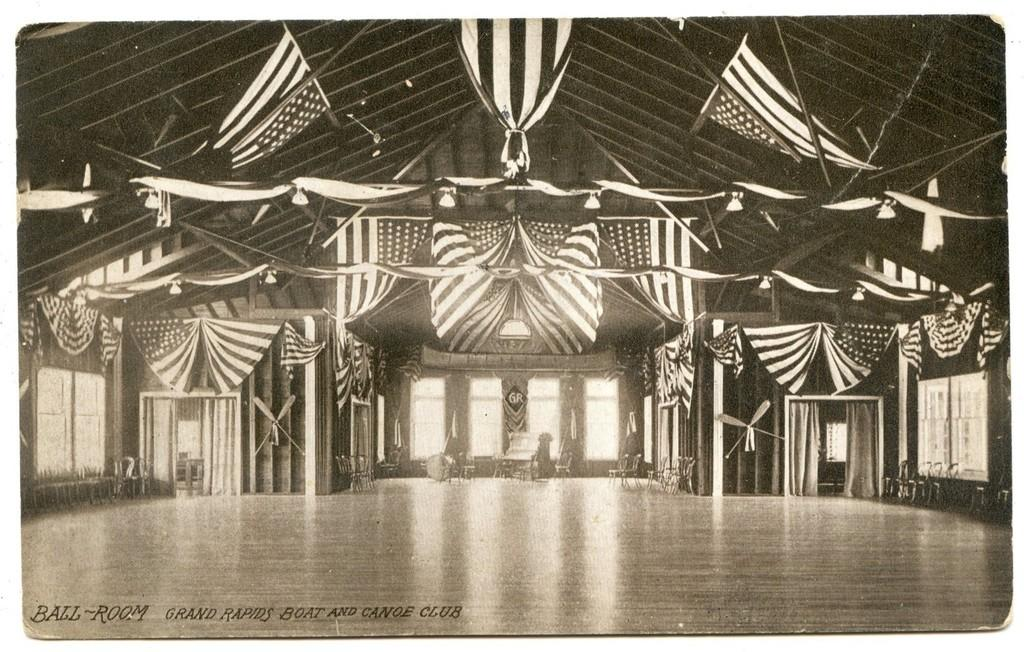What can be seen on the floor in the image? The floor is visible in the image, but no specific details about the floor are provided. What is visible through the windows in the image? There are windows in the image, but no specific details about what can be seen through them are provided. What type of window treatment is present in the image? Curtains are present in the image. What type of decoration or symbol is visible in the image? Flags are visible in the image. What type of furniture is present in the image? Chairs are present in the image. What is the color scheme of the image? The image is black and white. What type of pollution can be seen in the image? There is no pollution visible in the image. What direction is the prose facing in the image? There is no prose present in the image. 